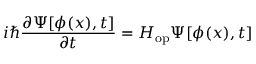Convert formula to latex. <formula><loc_0><loc_0><loc_500><loc_500>i \hbar { } \partial \Psi [ \phi ( x ) , t ] } { \partial t } = H _ { o p } \Psi [ \phi ( x ) , t ]</formula> 